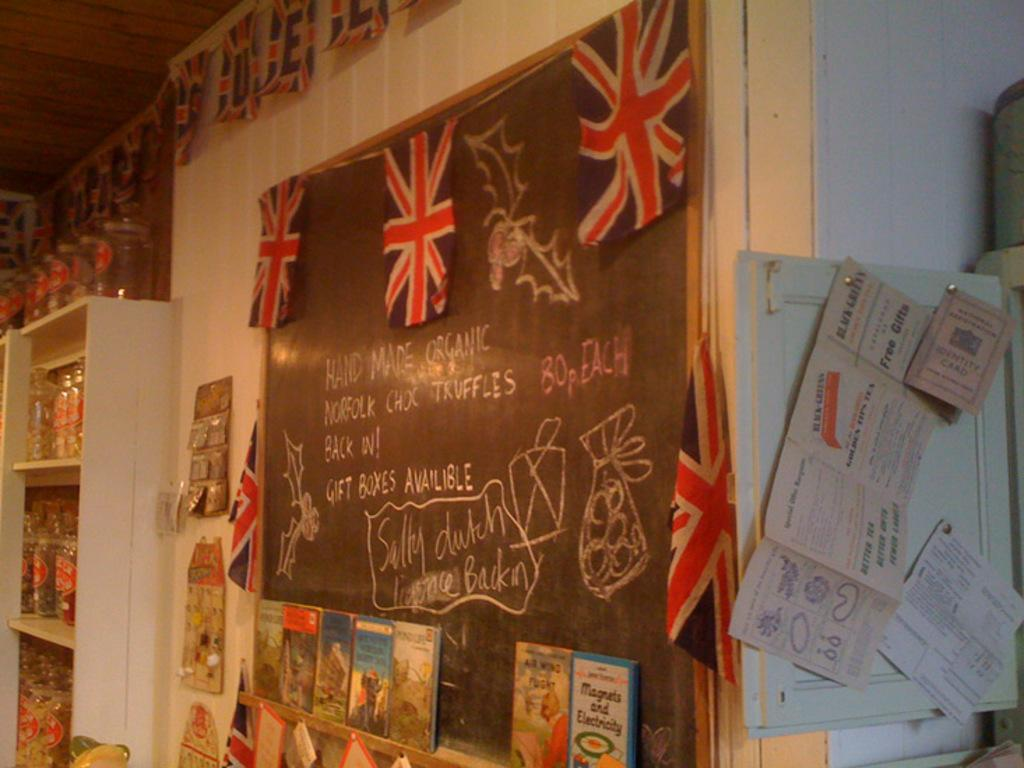<image>
Render a clear and concise summary of the photo. Blackboard on a wall with flags and a book under it for "Magnets and Electricity". 